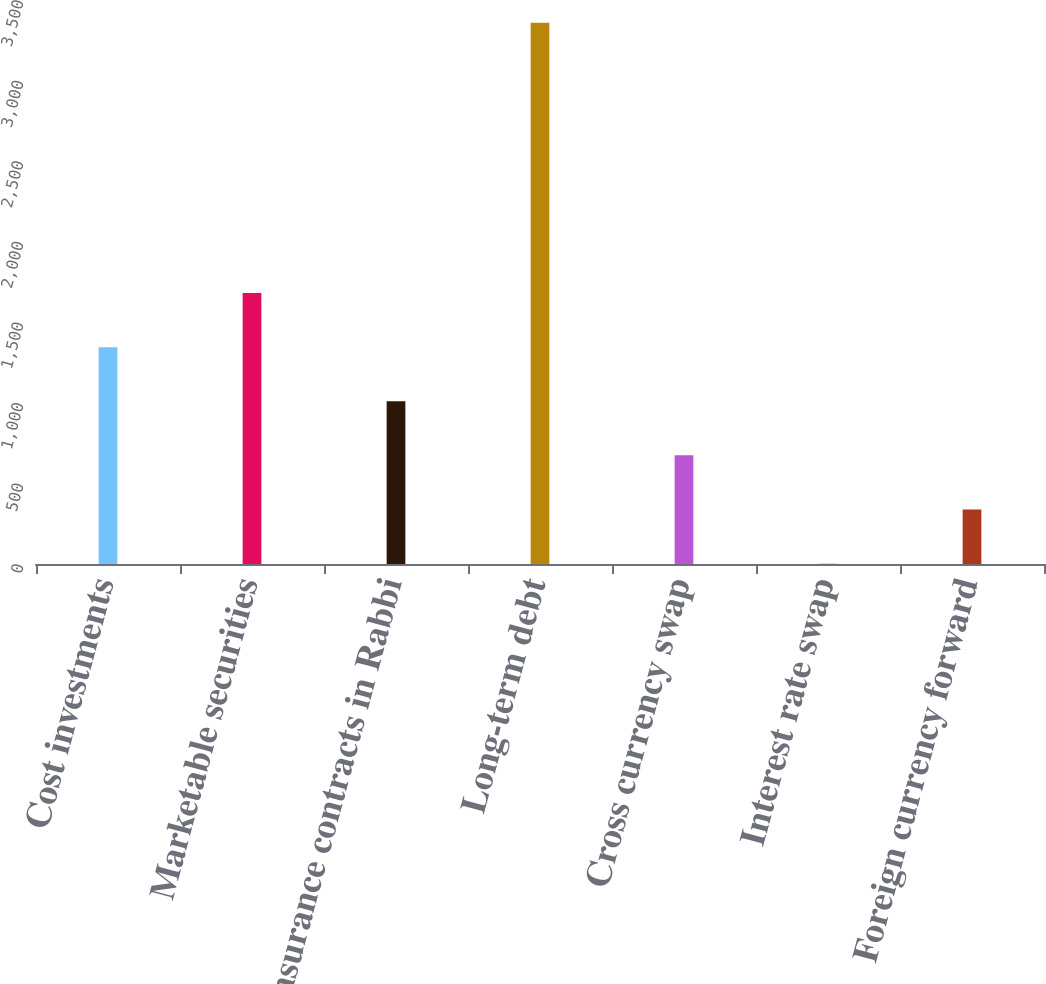Convert chart. <chart><loc_0><loc_0><loc_500><loc_500><bar_chart><fcel>Cost investments<fcel>Marketable securities<fcel>Insurance contracts in Rabbi<fcel>Long-term debt<fcel>Cross currency swap<fcel>Interest rate swap<fcel>Foreign currency forward<nl><fcel>1345.4<fcel>1681<fcel>1009.8<fcel>3359<fcel>674.2<fcel>3<fcel>338.6<nl></chart> 